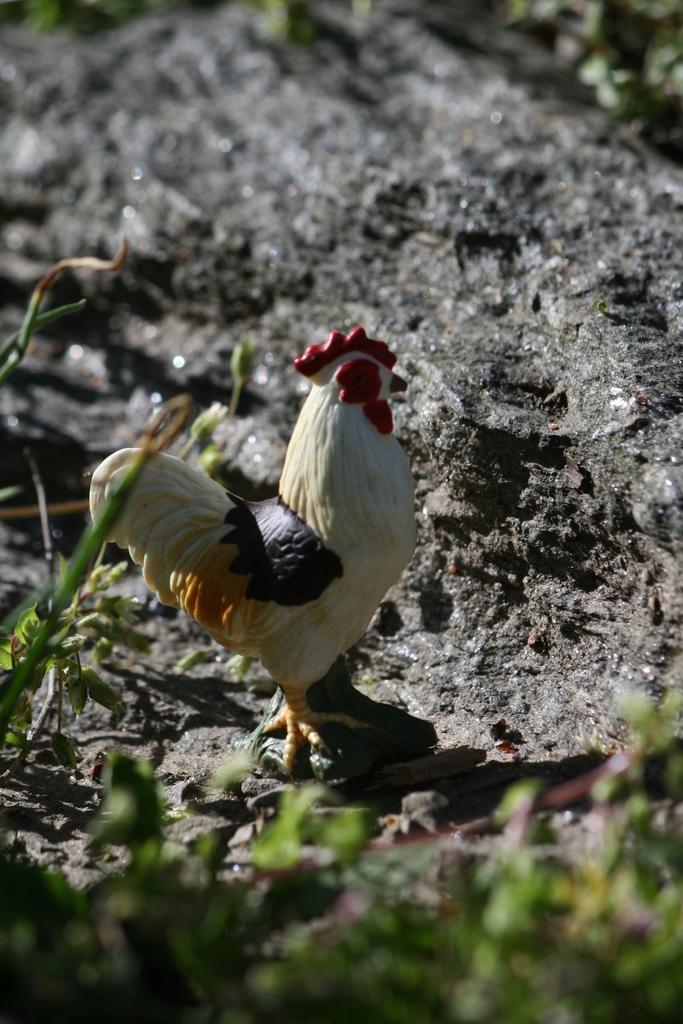Could you give a brief overview of what you see in this image? At the bottom of the image there are leaves. Behind the leaves there is a toy cock on the ground. 